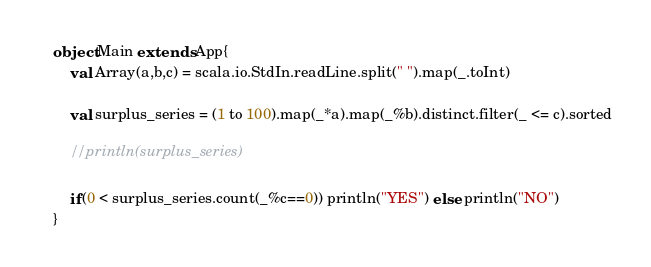Convert code to text. <code><loc_0><loc_0><loc_500><loc_500><_Scala_>object Main extends App{
    val Array(a,b,c) = scala.io.StdIn.readLine.split(" ").map(_.toInt)
    
    val surplus_series = (1 to 100).map(_*a).map(_%b).distinct.filter(_ <= c).sorted
    
    //println(surplus_series)
    
    if(0 < surplus_series.count(_%c==0)) println("YES") else println("NO")
}
</code> 